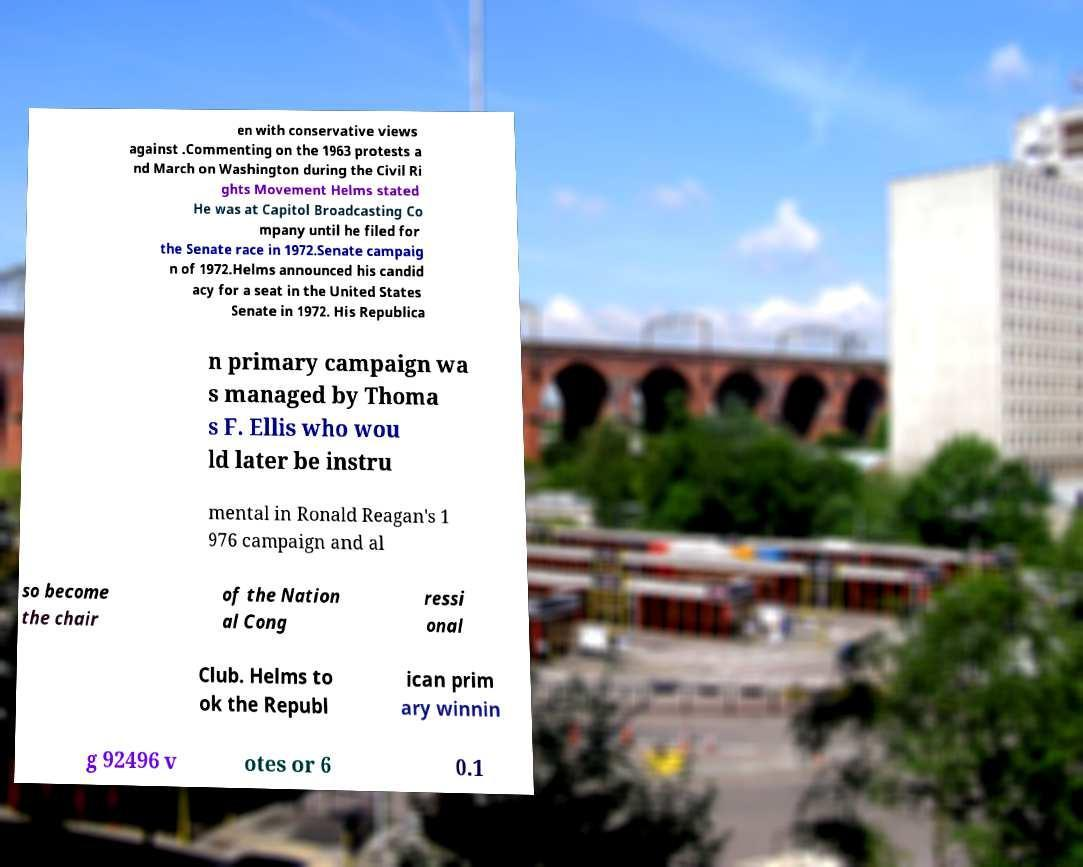Can you read and provide the text displayed in the image?This photo seems to have some interesting text. Can you extract and type it out for me? en with conservative views against .Commenting on the 1963 protests a nd March on Washington during the Civil Ri ghts Movement Helms stated He was at Capitol Broadcasting Co mpany until he filed for the Senate race in 1972.Senate campaig n of 1972.Helms announced his candid acy for a seat in the United States Senate in 1972. His Republica n primary campaign wa s managed by Thoma s F. Ellis who wou ld later be instru mental in Ronald Reagan's 1 976 campaign and al so become the chair of the Nation al Cong ressi onal Club. Helms to ok the Republ ican prim ary winnin g 92496 v otes or 6 0.1 